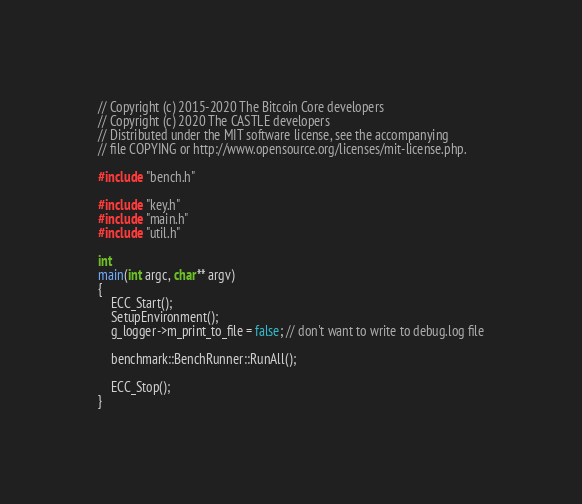Convert code to text. <code><loc_0><loc_0><loc_500><loc_500><_C++_>// Copyright (c) 2015-2020 The Bitcoin Core developers
// Copyright (c) 2020 The CASTLE developers
// Distributed under the MIT software license, see the accompanying
// file COPYING or http://www.opensource.org/licenses/mit-license.php.

#include "bench.h"

#include "key.h"
#include "main.h"
#include "util.h"

int
main(int argc, char** argv)
{
    ECC_Start();
    SetupEnvironment();
    g_logger->m_print_to_file = false; // don't want to write to debug.log file

    benchmark::BenchRunner::RunAll();

    ECC_Stop();
}
</code> 